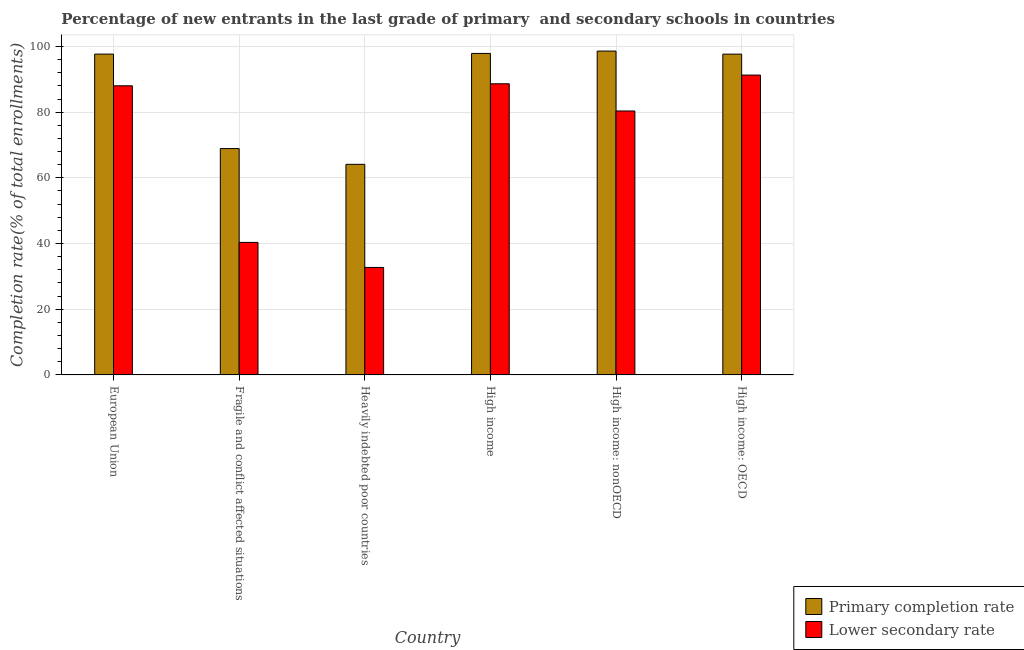How many different coloured bars are there?
Ensure brevity in your answer.  2. Are the number of bars per tick equal to the number of legend labels?
Offer a very short reply. Yes. Are the number of bars on each tick of the X-axis equal?
Offer a terse response. Yes. How many bars are there on the 1st tick from the left?
Offer a terse response. 2. How many bars are there on the 6th tick from the right?
Ensure brevity in your answer.  2. What is the label of the 5th group of bars from the left?
Your answer should be very brief. High income: nonOECD. What is the completion rate in secondary schools in Fragile and conflict affected situations?
Give a very brief answer. 40.34. Across all countries, what is the maximum completion rate in secondary schools?
Ensure brevity in your answer.  91.28. Across all countries, what is the minimum completion rate in primary schools?
Keep it short and to the point. 64.11. In which country was the completion rate in secondary schools maximum?
Provide a succinct answer. High income: OECD. In which country was the completion rate in primary schools minimum?
Provide a succinct answer. Heavily indebted poor countries. What is the total completion rate in primary schools in the graph?
Your answer should be very brief. 524.82. What is the difference between the completion rate in primary schools in Fragile and conflict affected situations and that in High income?
Provide a short and direct response. -28.97. What is the difference between the completion rate in primary schools in High income: OECD and the completion rate in secondary schools in Heavily indebted poor countries?
Provide a succinct answer. 64.94. What is the average completion rate in primary schools per country?
Your answer should be compact. 87.47. What is the difference between the completion rate in primary schools and completion rate in secondary schools in Fragile and conflict affected situations?
Provide a succinct answer. 28.57. What is the ratio of the completion rate in primary schools in Fragile and conflict affected situations to that in High income: nonOECD?
Your answer should be compact. 0.7. Is the completion rate in primary schools in High income less than that in High income: nonOECD?
Offer a very short reply. Yes. Is the difference between the completion rate in primary schools in European Union and Fragile and conflict affected situations greater than the difference between the completion rate in secondary schools in European Union and Fragile and conflict affected situations?
Offer a terse response. No. What is the difference between the highest and the second highest completion rate in primary schools?
Your answer should be very brief. 0.72. What is the difference between the highest and the lowest completion rate in primary schools?
Offer a terse response. 34.48. Is the sum of the completion rate in primary schools in Heavily indebted poor countries and High income: OECD greater than the maximum completion rate in secondary schools across all countries?
Give a very brief answer. Yes. What does the 1st bar from the left in European Union represents?
Keep it short and to the point. Primary completion rate. What does the 2nd bar from the right in European Union represents?
Make the answer very short. Primary completion rate. Are all the bars in the graph horizontal?
Ensure brevity in your answer.  No. Are the values on the major ticks of Y-axis written in scientific E-notation?
Keep it short and to the point. No. How are the legend labels stacked?
Make the answer very short. Vertical. What is the title of the graph?
Give a very brief answer. Percentage of new entrants in the last grade of primary  and secondary schools in countries. Does "From World Bank" appear as one of the legend labels in the graph?
Give a very brief answer. No. What is the label or title of the Y-axis?
Offer a very short reply. Completion rate(% of total enrollments). What is the Completion rate(% of total enrollments) of Primary completion rate in European Union?
Your answer should be compact. 97.67. What is the Completion rate(% of total enrollments) in Lower secondary rate in European Union?
Offer a very short reply. 88.02. What is the Completion rate(% of total enrollments) of Primary completion rate in Fragile and conflict affected situations?
Your response must be concise. 68.91. What is the Completion rate(% of total enrollments) in Lower secondary rate in Fragile and conflict affected situations?
Ensure brevity in your answer.  40.34. What is the Completion rate(% of total enrollments) in Primary completion rate in Heavily indebted poor countries?
Provide a succinct answer. 64.11. What is the Completion rate(% of total enrollments) of Lower secondary rate in Heavily indebted poor countries?
Your response must be concise. 32.72. What is the Completion rate(% of total enrollments) in Primary completion rate in High income?
Offer a very short reply. 97.88. What is the Completion rate(% of total enrollments) of Lower secondary rate in High income?
Provide a succinct answer. 88.63. What is the Completion rate(% of total enrollments) in Primary completion rate in High income: nonOECD?
Give a very brief answer. 98.59. What is the Completion rate(% of total enrollments) in Lower secondary rate in High income: nonOECD?
Provide a short and direct response. 80.35. What is the Completion rate(% of total enrollments) in Primary completion rate in High income: OECD?
Keep it short and to the point. 97.66. What is the Completion rate(% of total enrollments) in Lower secondary rate in High income: OECD?
Offer a terse response. 91.28. Across all countries, what is the maximum Completion rate(% of total enrollments) of Primary completion rate?
Your response must be concise. 98.59. Across all countries, what is the maximum Completion rate(% of total enrollments) in Lower secondary rate?
Your answer should be very brief. 91.28. Across all countries, what is the minimum Completion rate(% of total enrollments) in Primary completion rate?
Provide a short and direct response. 64.11. Across all countries, what is the minimum Completion rate(% of total enrollments) in Lower secondary rate?
Your answer should be compact. 32.72. What is the total Completion rate(% of total enrollments) of Primary completion rate in the graph?
Offer a very short reply. 524.82. What is the total Completion rate(% of total enrollments) of Lower secondary rate in the graph?
Ensure brevity in your answer.  421.36. What is the difference between the Completion rate(% of total enrollments) of Primary completion rate in European Union and that in Fragile and conflict affected situations?
Keep it short and to the point. 28.76. What is the difference between the Completion rate(% of total enrollments) in Lower secondary rate in European Union and that in Fragile and conflict affected situations?
Provide a succinct answer. 47.68. What is the difference between the Completion rate(% of total enrollments) in Primary completion rate in European Union and that in Heavily indebted poor countries?
Your answer should be very brief. 33.56. What is the difference between the Completion rate(% of total enrollments) of Lower secondary rate in European Union and that in Heavily indebted poor countries?
Keep it short and to the point. 55.31. What is the difference between the Completion rate(% of total enrollments) of Primary completion rate in European Union and that in High income?
Offer a terse response. -0.21. What is the difference between the Completion rate(% of total enrollments) in Lower secondary rate in European Union and that in High income?
Provide a succinct answer. -0.61. What is the difference between the Completion rate(% of total enrollments) in Primary completion rate in European Union and that in High income: nonOECD?
Keep it short and to the point. -0.92. What is the difference between the Completion rate(% of total enrollments) in Lower secondary rate in European Union and that in High income: nonOECD?
Provide a succinct answer. 7.67. What is the difference between the Completion rate(% of total enrollments) of Primary completion rate in European Union and that in High income: OECD?
Offer a very short reply. 0.01. What is the difference between the Completion rate(% of total enrollments) of Lower secondary rate in European Union and that in High income: OECD?
Make the answer very short. -3.26. What is the difference between the Completion rate(% of total enrollments) of Primary completion rate in Fragile and conflict affected situations and that in Heavily indebted poor countries?
Give a very brief answer. 4.8. What is the difference between the Completion rate(% of total enrollments) of Lower secondary rate in Fragile and conflict affected situations and that in Heavily indebted poor countries?
Keep it short and to the point. 7.63. What is the difference between the Completion rate(% of total enrollments) of Primary completion rate in Fragile and conflict affected situations and that in High income?
Make the answer very short. -28.97. What is the difference between the Completion rate(% of total enrollments) in Lower secondary rate in Fragile and conflict affected situations and that in High income?
Your response must be concise. -48.29. What is the difference between the Completion rate(% of total enrollments) in Primary completion rate in Fragile and conflict affected situations and that in High income: nonOECD?
Provide a succinct answer. -29.68. What is the difference between the Completion rate(% of total enrollments) of Lower secondary rate in Fragile and conflict affected situations and that in High income: nonOECD?
Provide a short and direct response. -40.01. What is the difference between the Completion rate(% of total enrollments) of Primary completion rate in Fragile and conflict affected situations and that in High income: OECD?
Offer a very short reply. -28.75. What is the difference between the Completion rate(% of total enrollments) in Lower secondary rate in Fragile and conflict affected situations and that in High income: OECD?
Offer a very short reply. -50.94. What is the difference between the Completion rate(% of total enrollments) of Primary completion rate in Heavily indebted poor countries and that in High income?
Provide a succinct answer. -33.77. What is the difference between the Completion rate(% of total enrollments) of Lower secondary rate in Heavily indebted poor countries and that in High income?
Offer a very short reply. -55.92. What is the difference between the Completion rate(% of total enrollments) in Primary completion rate in Heavily indebted poor countries and that in High income: nonOECD?
Offer a terse response. -34.48. What is the difference between the Completion rate(% of total enrollments) of Lower secondary rate in Heavily indebted poor countries and that in High income: nonOECD?
Keep it short and to the point. -47.64. What is the difference between the Completion rate(% of total enrollments) in Primary completion rate in Heavily indebted poor countries and that in High income: OECD?
Your answer should be very brief. -33.55. What is the difference between the Completion rate(% of total enrollments) in Lower secondary rate in Heavily indebted poor countries and that in High income: OECD?
Provide a short and direct response. -58.57. What is the difference between the Completion rate(% of total enrollments) of Primary completion rate in High income and that in High income: nonOECD?
Provide a succinct answer. -0.72. What is the difference between the Completion rate(% of total enrollments) of Lower secondary rate in High income and that in High income: nonOECD?
Give a very brief answer. 8.28. What is the difference between the Completion rate(% of total enrollments) in Primary completion rate in High income and that in High income: OECD?
Keep it short and to the point. 0.22. What is the difference between the Completion rate(% of total enrollments) in Lower secondary rate in High income and that in High income: OECD?
Provide a succinct answer. -2.65. What is the difference between the Completion rate(% of total enrollments) in Primary completion rate in High income: nonOECD and that in High income: OECD?
Provide a short and direct response. 0.93. What is the difference between the Completion rate(% of total enrollments) in Lower secondary rate in High income: nonOECD and that in High income: OECD?
Offer a very short reply. -10.93. What is the difference between the Completion rate(% of total enrollments) of Primary completion rate in European Union and the Completion rate(% of total enrollments) of Lower secondary rate in Fragile and conflict affected situations?
Give a very brief answer. 57.33. What is the difference between the Completion rate(% of total enrollments) in Primary completion rate in European Union and the Completion rate(% of total enrollments) in Lower secondary rate in Heavily indebted poor countries?
Make the answer very short. 64.95. What is the difference between the Completion rate(% of total enrollments) in Primary completion rate in European Union and the Completion rate(% of total enrollments) in Lower secondary rate in High income?
Offer a terse response. 9.04. What is the difference between the Completion rate(% of total enrollments) of Primary completion rate in European Union and the Completion rate(% of total enrollments) of Lower secondary rate in High income: nonOECD?
Provide a short and direct response. 17.32. What is the difference between the Completion rate(% of total enrollments) in Primary completion rate in European Union and the Completion rate(% of total enrollments) in Lower secondary rate in High income: OECD?
Offer a very short reply. 6.39. What is the difference between the Completion rate(% of total enrollments) in Primary completion rate in Fragile and conflict affected situations and the Completion rate(% of total enrollments) in Lower secondary rate in Heavily indebted poor countries?
Ensure brevity in your answer.  36.19. What is the difference between the Completion rate(% of total enrollments) in Primary completion rate in Fragile and conflict affected situations and the Completion rate(% of total enrollments) in Lower secondary rate in High income?
Your answer should be compact. -19.72. What is the difference between the Completion rate(% of total enrollments) of Primary completion rate in Fragile and conflict affected situations and the Completion rate(% of total enrollments) of Lower secondary rate in High income: nonOECD?
Your response must be concise. -11.44. What is the difference between the Completion rate(% of total enrollments) of Primary completion rate in Fragile and conflict affected situations and the Completion rate(% of total enrollments) of Lower secondary rate in High income: OECD?
Provide a succinct answer. -22.37. What is the difference between the Completion rate(% of total enrollments) of Primary completion rate in Heavily indebted poor countries and the Completion rate(% of total enrollments) of Lower secondary rate in High income?
Make the answer very short. -24.52. What is the difference between the Completion rate(% of total enrollments) in Primary completion rate in Heavily indebted poor countries and the Completion rate(% of total enrollments) in Lower secondary rate in High income: nonOECD?
Offer a terse response. -16.24. What is the difference between the Completion rate(% of total enrollments) of Primary completion rate in Heavily indebted poor countries and the Completion rate(% of total enrollments) of Lower secondary rate in High income: OECD?
Your answer should be compact. -27.17. What is the difference between the Completion rate(% of total enrollments) in Primary completion rate in High income and the Completion rate(% of total enrollments) in Lower secondary rate in High income: nonOECD?
Offer a very short reply. 17.52. What is the difference between the Completion rate(% of total enrollments) of Primary completion rate in High income and the Completion rate(% of total enrollments) of Lower secondary rate in High income: OECD?
Your response must be concise. 6.59. What is the difference between the Completion rate(% of total enrollments) in Primary completion rate in High income: nonOECD and the Completion rate(% of total enrollments) in Lower secondary rate in High income: OECD?
Give a very brief answer. 7.31. What is the average Completion rate(% of total enrollments) in Primary completion rate per country?
Your answer should be very brief. 87.47. What is the average Completion rate(% of total enrollments) of Lower secondary rate per country?
Your response must be concise. 70.23. What is the difference between the Completion rate(% of total enrollments) of Primary completion rate and Completion rate(% of total enrollments) of Lower secondary rate in European Union?
Your answer should be compact. 9.65. What is the difference between the Completion rate(% of total enrollments) of Primary completion rate and Completion rate(% of total enrollments) of Lower secondary rate in Fragile and conflict affected situations?
Your answer should be compact. 28.57. What is the difference between the Completion rate(% of total enrollments) in Primary completion rate and Completion rate(% of total enrollments) in Lower secondary rate in Heavily indebted poor countries?
Provide a succinct answer. 31.39. What is the difference between the Completion rate(% of total enrollments) in Primary completion rate and Completion rate(% of total enrollments) in Lower secondary rate in High income?
Offer a very short reply. 9.24. What is the difference between the Completion rate(% of total enrollments) of Primary completion rate and Completion rate(% of total enrollments) of Lower secondary rate in High income: nonOECD?
Keep it short and to the point. 18.24. What is the difference between the Completion rate(% of total enrollments) in Primary completion rate and Completion rate(% of total enrollments) in Lower secondary rate in High income: OECD?
Keep it short and to the point. 6.38. What is the ratio of the Completion rate(% of total enrollments) of Primary completion rate in European Union to that in Fragile and conflict affected situations?
Ensure brevity in your answer.  1.42. What is the ratio of the Completion rate(% of total enrollments) of Lower secondary rate in European Union to that in Fragile and conflict affected situations?
Provide a short and direct response. 2.18. What is the ratio of the Completion rate(% of total enrollments) in Primary completion rate in European Union to that in Heavily indebted poor countries?
Keep it short and to the point. 1.52. What is the ratio of the Completion rate(% of total enrollments) of Lower secondary rate in European Union to that in Heavily indebted poor countries?
Offer a terse response. 2.69. What is the ratio of the Completion rate(% of total enrollments) in Lower secondary rate in European Union to that in High income?
Offer a terse response. 0.99. What is the ratio of the Completion rate(% of total enrollments) in Primary completion rate in European Union to that in High income: nonOECD?
Give a very brief answer. 0.99. What is the ratio of the Completion rate(% of total enrollments) in Lower secondary rate in European Union to that in High income: nonOECD?
Provide a succinct answer. 1.1. What is the ratio of the Completion rate(% of total enrollments) in Lower secondary rate in European Union to that in High income: OECD?
Your response must be concise. 0.96. What is the ratio of the Completion rate(% of total enrollments) of Primary completion rate in Fragile and conflict affected situations to that in Heavily indebted poor countries?
Offer a terse response. 1.07. What is the ratio of the Completion rate(% of total enrollments) in Lower secondary rate in Fragile and conflict affected situations to that in Heavily indebted poor countries?
Offer a terse response. 1.23. What is the ratio of the Completion rate(% of total enrollments) in Primary completion rate in Fragile and conflict affected situations to that in High income?
Provide a short and direct response. 0.7. What is the ratio of the Completion rate(% of total enrollments) of Lower secondary rate in Fragile and conflict affected situations to that in High income?
Give a very brief answer. 0.46. What is the ratio of the Completion rate(% of total enrollments) in Primary completion rate in Fragile and conflict affected situations to that in High income: nonOECD?
Make the answer very short. 0.7. What is the ratio of the Completion rate(% of total enrollments) in Lower secondary rate in Fragile and conflict affected situations to that in High income: nonOECD?
Give a very brief answer. 0.5. What is the ratio of the Completion rate(% of total enrollments) in Primary completion rate in Fragile and conflict affected situations to that in High income: OECD?
Provide a succinct answer. 0.71. What is the ratio of the Completion rate(% of total enrollments) in Lower secondary rate in Fragile and conflict affected situations to that in High income: OECD?
Your answer should be very brief. 0.44. What is the ratio of the Completion rate(% of total enrollments) of Primary completion rate in Heavily indebted poor countries to that in High income?
Keep it short and to the point. 0.66. What is the ratio of the Completion rate(% of total enrollments) in Lower secondary rate in Heavily indebted poor countries to that in High income?
Offer a terse response. 0.37. What is the ratio of the Completion rate(% of total enrollments) of Primary completion rate in Heavily indebted poor countries to that in High income: nonOECD?
Your response must be concise. 0.65. What is the ratio of the Completion rate(% of total enrollments) in Lower secondary rate in Heavily indebted poor countries to that in High income: nonOECD?
Provide a succinct answer. 0.41. What is the ratio of the Completion rate(% of total enrollments) in Primary completion rate in Heavily indebted poor countries to that in High income: OECD?
Your answer should be very brief. 0.66. What is the ratio of the Completion rate(% of total enrollments) in Lower secondary rate in Heavily indebted poor countries to that in High income: OECD?
Ensure brevity in your answer.  0.36. What is the ratio of the Completion rate(% of total enrollments) of Lower secondary rate in High income to that in High income: nonOECD?
Offer a very short reply. 1.1. What is the ratio of the Completion rate(% of total enrollments) in Primary completion rate in High income to that in High income: OECD?
Ensure brevity in your answer.  1. What is the ratio of the Completion rate(% of total enrollments) in Lower secondary rate in High income to that in High income: OECD?
Your response must be concise. 0.97. What is the ratio of the Completion rate(% of total enrollments) in Primary completion rate in High income: nonOECD to that in High income: OECD?
Give a very brief answer. 1.01. What is the ratio of the Completion rate(% of total enrollments) of Lower secondary rate in High income: nonOECD to that in High income: OECD?
Offer a terse response. 0.88. What is the difference between the highest and the second highest Completion rate(% of total enrollments) in Primary completion rate?
Provide a succinct answer. 0.72. What is the difference between the highest and the second highest Completion rate(% of total enrollments) in Lower secondary rate?
Keep it short and to the point. 2.65. What is the difference between the highest and the lowest Completion rate(% of total enrollments) in Primary completion rate?
Offer a very short reply. 34.48. What is the difference between the highest and the lowest Completion rate(% of total enrollments) in Lower secondary rate?
Make the answer very short. 58.57. 